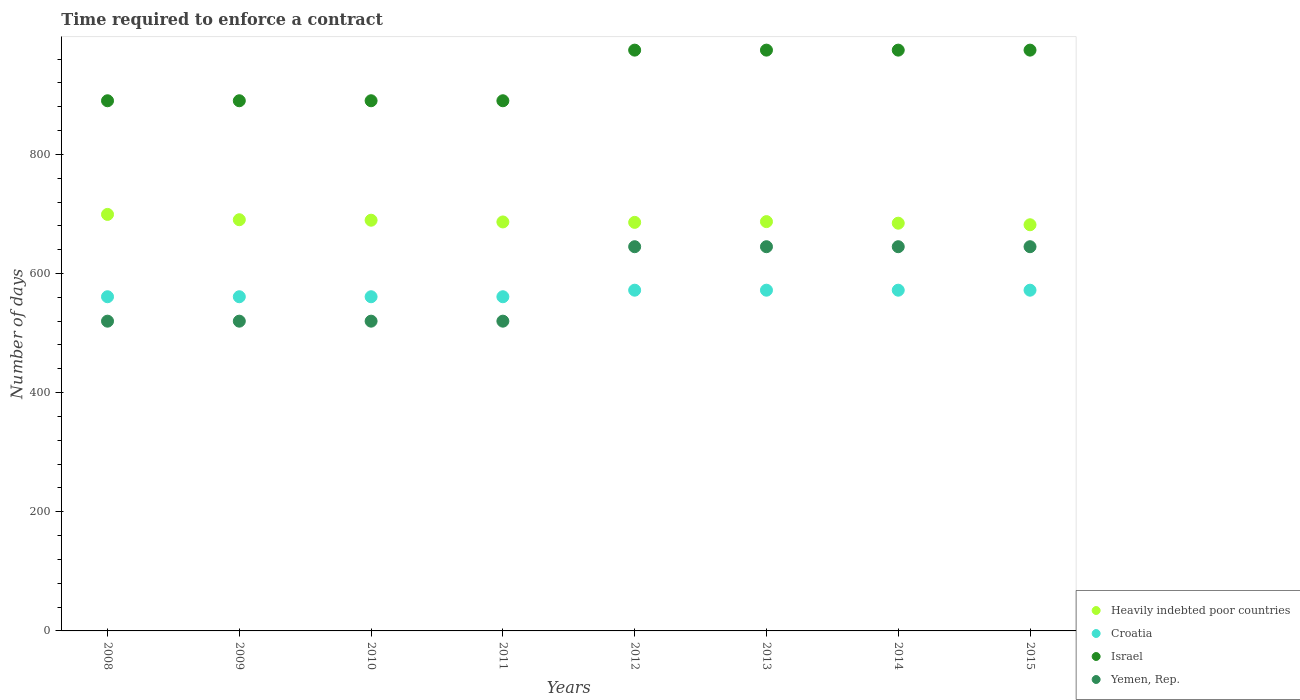How many different coloured dotlines are there?
Ensure brevity in your answer.  4. Is the number of dotlines equal to the number of legend labels?
Provide a succinct answer. Yes. What is the number of days required to enforce a contract in Heavily indebted poor countries in 2012?
Your response must be concise. 685.84. Across all years, what is the maximum number of days required to enforce a contract in Yemen, Rep.?
Make the answer very short. 645. Across all years, what is the minimum number of days required to enforce a contract in Israel?
Your answer should be very brief. 890. In which year was the number of days required to enforce a contract in Croatia maximum?
Provide a short and direct response. 2012. In which year was the number of days required to enforce a contract in Heavily indebted poor countries minimum?
Provide a succinct answer. 2015. What is the total number of days required to enforce a contract in Heavily indebted poor countries in the graph?
Your response must be concise. 5504.79. What is the difference between the number of days required to enforce a contract in Croatia in 2011 and that in 2012?
Provide a short and direct response. -11. What is the difference between the number of days required to enforce a contract in Yemen, Rep. in 2010 and the number of days required to enforce a contract in Croatia in 2009?
Ensure brevity in your answer.  -41. What is the average number of days required to enforce a contract in Croatia per year?
Ensure brevity in your answer.  566.5. In the year 2008, what is the difference between the number of days required to enforce a contract in Croatia and number of days required to enforce a contract in Yemen, Rep.?
Provide a short and direct response. 41. In how many years, is the number of days required to enforce a contract in Yemen, Rep. greater than 320 days?
Offer a terse response. 8. What is the difference between the highest and the second highest number of days required to enforce a contract in Heavily indebted poor countries?
Make the answer very short. 8.92. What is the difference between the highest and the lowest number of days required to enforce a contract in Heavily indebted poor countries?
Give a very brief answer. 17.37. Is it the case that in every year, the sum of the number of days required to enforce a contract in Yemen, Rep. and number of days required to enforce a contract in Israel  is greater than the sum of number of days required to enforce a contract in Croatia and number of days required to enforce a contract in Heavily indebted poor countries?
Give a very brief answer. Yes. Is it the case that in every year, the sum of the number of days required to enforce a contract in Heavily indebted poor countries and number of days required to enforce a contract in Croatia  is greater than the number of days required to enforce a contract in Israel?
Offer a very short reply. Yes. Does the number of days required to enforce a contract in Heavily indebted poor countries monotonically increase over the years?
Make the answer very short. No. Is the number of days required to enforce a contract in Heavily indebted poor countries strictly greater than the number of days required to enforce a contract in Yemen, Rep. over the years?
Your response must be concise. Yes. How many years are there in the graph?
Make the answer very short. 8. Are the values on the major ticks of Y-axis written in scientific E-notation?
Offer a terse response. No. Does the graph contain grids?
Your answer should be very brief. No. Where does the legend appear in the graph?
Keep it short and to the point. Bottom right. How many legend labels are there?
Your answer should be compact. 4. How are the legend labels stacked?
Provide a short and direct response. Vertical. What is the title of the graph?
Give a very brief answer. Time required to enforce a contract. What is the label or title of the X-axis?
Provide a succinct answer. Years. What is the label or title of the Y-axis?
Keep it short and to the point. Number of days. What is the Number of days of Heavily indebted poor countries in 2008?
Keep it short and to the point. 699.21. What is the Number of days of Croatia in 2008?
Provide a short and direct response. 561. What is the Number of days in Israel in 2008?
Provide a short and direct response. 890. What is the Number of days of Yemen, Rep. in 2008?
Offer a very short reply. 520. What is the Number of days of Heavily indebted poor countries in 2009?
Keep it short and to the point. 690.29. What is the Number of days of Croatia in 2009?
Offer a terse response. 561. What is the Number of days in Israel in 2009?
Keep it short and to the point. 890. What is the Number of days of Yemen, Rep. in 2009?
Keep it short and to the point. 520. What is the Number of days in Heavily indebted poor countries in 2010?
Your response must be concise. 689.47. What is the Number of days of Croatia in 2010?
Give a very brief answer. 561. What is the Number of days of Israel in 2010?
Ensure brevity in your answer.  890. What is the Number of days of Yemen, Rep. in 2010?
Keep it short and to the point. 520. What is the Number of days of Heavily indebted poor countries in 2011?
Your response must be concise. 686.55. What is the Number of days of Croatia in 2011?
Provide a short and direct response. 561. What is the Number of days in Israel in 2011?
Make the answer very short. 890. What is the Number of days in Yemen, Rep. in 2011?
Provide a short and direct response. 520. What is the Number of days of Heavily indebted poor countries in 2012?
Offer a terse response. 685.84. What is the Number of days in Croatia in 2012?
Offer a very short reply. 572. What is the Number of days of Israel in 2012?
Provide a short and direct response. 975. What is the Number of days of Yemen, Rep. in 2012?
Your response must be concise. 645. What is the Number of days in Heavily indebted poor countries in 2013?
Give a very brief answer. 687.11. What is the Number of days in Croatia in 2013?
Provide a short and direct response. 572. What is the Number of days of Israel in 2013?
Your answer should be compact. 975. What is the Number of days of Yemen, Rep. in 2013?
Ensure brevity in your answer.  645. What is the Number of days of Heavily indebted poor countries in 2014?
Keep it short and to the point. 684.47. What is the Number of days in Croatia in 2014?
Keep it short and to the point. 572. What is the Number of days in Israel in 2014?
Your answer should be very brief. 975. What is the Number of days of Yemen, Rep. in 2014?
Your answer should be very brief. 645. What is the Number of days in Heavily indebted poor countries in 2015?
Keep it short and to the point. 681.84. What is the Number of days in Croatia in 2015?
Ensure brevity in your answer.  572. What is the Number of days of Israel in 2015?
Offer a terse response. 975. What is the Number of days in Yemen, Rep. in 2015?
Keep it short and to the point. 645. Across all years, what is the maximum Number of days of Heavily indebted poor countries?
Make the answer very short. 699.21. Across all years, what is the maximum Number of days of Croatia?
Your response must be concise. 572. Across all years, what is the maximum Number of days of Israel?
Your response must be concise. 975. Across all years, what is the maximum Number of days in Yemen, Rep.?
Your answer should be very brief. 645. Across all years, what is the minimum Number of days in Heavily indebted poor countries?
Make the answer very short. 681.84. Across all years, what is the minimum Number of days in Croatia?
Give a very brief answer. 561. Across all years, what is the minimum Number of days of Israel?
Make the answer very short. 890. Across all years, what is the minimum Number of days in Yemen, Rep.?
Offer a very short reply. 520. What is the total Number of days in Heavily indebted poor countries in the graph?
Your response must be concise. 5504.79. What is the total Number of days of Croatia in the graph?
Offer a very short reply. 4532. What is the total Number of days of Israel in the graph?
Give a very brief answer. 7460. What is the total Number of days in Yemen, Rep. in the graph?
Your answer should be very brief. 4660. What is the difference between the Number of days in Heavily indebted poor countries in 2008 and that in 2009?
Ensure brevity in your answer.  8.92. What is the difference between the Number of days of Croatia in 2008 and that in 2009?
Provide a succinct answer. 0. What is the difference between the Number of days of Israel in 2008 and that in 2009?
Offer a terse response. 0. What is the difference between the Number of days of Yemen, Rep. in 2008 and that in 2009?
Your response must be concise. 0. What is the difference between the Number of days in Heavily indebted poor countries in 2008 and that in 2010?
Keep it short and to the point. 9.74. What is the difference between the Number of days in Croatia in 2008 and that in 2010?
Your answer should be compact. 0. What is the difference between the Number of days of Yemen, Rep. in 2008 and that in 2010?
Your answer should be very brief. 0. What is the difference between the Number of days of Heavily indebted poor countries in 2008 and that in 2011?
Make the answer very short. 12.66. What is the difference between the Number of days of Croatia in 2008 and that in 2011?
Give a very brief answer. 0. What is the difference between the Number of days in Israel in 2008 and that in 2011?
Your response must be concise. 0. What is the difference between the Number of days in Heavily indebted poor countries in 2008 and that in 2012?
Your answer should be very brief. 13.37. What is the difference between the Number of days in Croatia in 2008 and that in 2012?
Your answer should be compact. -11. What is the difference between the Number of days of Israel in 2008 and that in 2012?
Ensure brevity in your answer.  -85. What is the difference between the Number of days of Yemen, Rep. in 2008 and that in 2012?
Provide a succinct answer. -125. What is the difference between the Number of days of Heavily indebted poor countries in 2008 and that in 2013?
Ensure brevity in your answer.  12.11. What is the difference between the Number of days of Israel in 2008 and that in 2013?
Make the answer very short. -85. What is the difference between the Number of days in Yemen, Rep. in 2008 and that in 2013?
Your answer should be very brief. -125. What is the difference between the Number of days in Heavily indebted poor countries in 2008 and that in 2014?
Your response must be concise. 14.74. What is the difference between the Number of days in Israel in 2008 and that in 2014?
Ensure brevity in your answer.  -85. What is the difference between the Number of days of Yemen, Rep. in 2008 and that in 2014?
Ensure brevity in your answer.  -125. What is the difference between the Number of days of Heavily indebted poor countries in 2008 and that in 2015?
Provide a succinct answer. 17.37. What is the difference between the Number of days in Israel in 2008 and that in 2015?
Ensure brevity in your answer.  -85. What is the difference between the Number of days in Yemen, Rep. in 2008 and that in 2015?
Offer a terse response. -125. What is the difference between the Number of days of Heavily indebted poor countries in 2009 and that in 2010?
Give a very brief answer. 0.82. What is the difference between the Number of days in Croatia in 2009 and that in 2010?
Give a very brief answer. 0. What is the difference between the Number of days in Yemen, Rep. in 2009 and that in 2010?
Give a very brief answer. 0. What is the difference between the Number of days in Heavily indebted poor countries in 2009 and that in 2011?
Give a very brief answer. 3.74. What is the difference between the Number of days of Heavily indebted poor countries in 2009 and that in 2012?
Ensure brevity in your answer.  4.45. What is the difference between the Number of days of Israel in 2009 and that in 2012?
Provide a succinct answer. -85. What is the difference between the Number of days of Yemen, Rep. in 2009 and that in 2012?
Ensure brevity in your answer.  -125. What is the difference between the Number of days of Heavily indebted poor countries in 2009 and that in 2013?
Offer a very short reply. 3.18. What is the difference between the Number of days of Israel in 2009 and that in 2013?
Your answer should be compact. -85. What is the difference between the Number of days of Yemen, Rep. in 2009 and that in 2013?
Keep it short and to the point. -125. What is the difference between the Number of days of Heavily indebted poor countries in 2009 and that in 2014?
Your answer should be compact. 5.82. What is the difference between the Number of days in Croatia in 2009 and that in 2014?
Provide a short and direct response. -11. What is the difference between the Number of days of Israel in 2009 and that in 2014?
Keep it short and to the point. -85. What is the difference between the Number of days of Yemen, Rep. in 2009 and that in 2014?
Your response must be concise. -125. What is the difference between the Number of days of Heavily indebted poor countries in 2009 and that in 2015?
Provide a short and direct response. 8.45. What is the difference between the Number of days of Croatia in 2009 and that in 2015?
Offer a very short reply. -11. What is the difference between the Number of days of Israel in 2009 and that in 2015?
Provide a succinct answer. -85. What is the difference between the Number of days of Yemen, Rep. in 2009 and that in 2015?
Provide a short and direct response. -125. What is the difference between the Number of days in Heavily indebted poor countries in 2010 and that in 2011?
Ensure brevity in your answer.  2.92. What is the difference between the Number of days of Croatia in 2010 and that in 2011?
Ensure brevity in your answer.  0. What is the difference between the Number of days of Israel in 2010 and that in 2011?
Make the answer very short. 0. What is the difference between the Number of days of Heavily indebted poor countries in 2010 and that in 2012?
Your answer should be compact. 3.63. What is the difference between the Number of days in Croatia in 2010 and that in 2012?
Keep it short and to the point. -11. What is the difference between the Number of days in Israel in 2010 and that in 2012?
Make the answer very short. -85. What is the difference between the Number of days of Yemen, Rep. in 2010 and that in 2012?
Ensure brevity in your answer.  -125. What is the difference between the Number of days of Heavily indebted poor countries in 2010 and that in 2013?
Your answer should be very brief. 2.37. What is the difference between the Number of days in Israel in 2010 and that in 2013?
Your answer should be compact. -85. What is the difference between the Number of days in Yemen, Rep. in 2010 and that in 2013?
Provide a short and direct response. -125. What is the difference between the Number of days of Heavily indebted poor countries in 2010 and that in 2014?
Ensure brevity in your answer.  5. What is the difference between the Number of days of Croatia in 2010 and that in 2014?
Offer a very short reply. -11. What is the difference between the Number of days of Israel in 2010 and that in 2014?
Give a very brief answer. -85. What is the difference between the Number of days of Yemen, Rep. in 2010 and that in 2014?
Ensure brevity in your answer.  -125. What is the difference between the Number of days of Heavily indebted poor countries in 2010 and that in 2015?
Make the answer very short. 7.63. What is the difference between the Number of days of Israel in 2010 and that in 2015?
Make the answer very short. -85. What is the difference between the Number of days of Yemen, Rep. in 2010 and that in 2015?
Ensure brevity in your answer.  -125. What is the difference between the Number of days of Heavily indebted poor countries in 2011 and that in 2012?
Give a very brief answer. 0.71. What is the difference between the Number of days in Israel in 2011 and that in 2012?
Your answer should be compact. -85. What is the difference between the Number of days of Yemen, Rep. in 2011 and that in 2012?
Keep it short and to the point. -125. What is the difference between the Number of days of Heavily indebted poor countries in 2011 and that in 2013?
Make the answer very short. -0.55. What is the difference between the Number of days of Croatia in 2011 and that in 2013?
Your response must be concise. -11. What is the difference between the Number of days in Israel in 2011 and that in 2013?
Your answer should be very brief. -85. What is the difference between the Number of days of Yemen, Rep. in 2011 and that in 2013?
Ensure brevity in your answer.  -125. What is the difference between the Number of days of Heavily indebted poor countries in 2011 and that in 2014?
Your answer should be compact. 2.08. What is the difference between the Number of days in Croatia in 2011 and that in 2014?
Offer a terse response. -11. What is the difference between the Number of days of Israel in 2011 and that in 2014?
Give a very brief answer. -85. What is the difference between the Number of days in Yemen, Rep. in 2011 and that in 2014?
Your response must be concise. -125. What is the difference between the Number of days of Heavily indebted poor countries in 2011 and that in 2015?
Your response must be concise. 4.71. What is the difference between the Number of days in Israel in 2011 and that in 2015?
Provide a succinct answer. -85. What is the difference between the Number of days in Yemen, Rep. in 2011 and that in 2015?
Provide a succinct answer. -125. What is the difference between the Number of days of Heavily indebted poor countries in 2012 and that in 2013?
Your answer should be very brief. -1.26. What is the difference between the Number of days of Heavily indebted poor countries in 2012 and that in 2014?
Make the answer very short. 1.37. What is the difference between the Number of days of Croatia in 2012 and that in 2014?
Give a very brief answer. 0. What is the difference between the Number of days of Yemen, Rep. in 2012 and that in 2014?
Your answer should be compact. 0. What is the difference between the Number of days in Israel in 2012 and that in 2015?
Your response must be concise. 0. What is the difference between the Number of days in Heavily indebted poor countries in 2013 and that in 2014?
Give a very brief answer. 2.63. What is the difference between the Number of days in Israel in 2013 and that in 2014?
Keep it short and to the point. 0. What is the difference between the Number of days of Heavily indebted poor countries in 2013 and that in 2015?
Provide a short and direct response. 5.26. What is the difference between the Number of days in Croatia in 2013 and that in 2015?
Your response must be concise. 0. What is the difference between the Number of days in Israel in 2013 and that in 2015?
Your answer should be compact. 0. What is the difference between the Number of days in Heavily indebted poor countries in 2014 and that in 2015?
Make the answer very short. 2.63. What is the difference between the Number of days in Heavily indebted poor countries in 2008 and the Number of days in Croatia in 2009?
Ensure brevity in your answer.  138.21. What is the difference between the Number of days in Heavily indebted poor countries in 2008 and the Number of days in Israel in 2009?
Make the answer very short. -190.79. What is the difference between the Number of days in Heavily indebted poor countries in 2008 and the Number of days in Yemen, Rep. in 2009?
Offer a terse response. 179.21. What is the difference between the Number of days in Croatia in 2008 and the Number of days in Israel in 2009?
Offer a very short reply. -329. What is the difference between the Number of days of Croatia in 2008 and the Number of days of Yemen, Rep. in 2009?
Give a very brief answer. 41. What is the difference between the Number of days in Israel in 2008 and the Number of days in Yemen, Rep. in 2009?
Provide a short and direct response. 370. What is the difference between the Number of days in Heavily indebted poor countries in 2008 and the Number of days in Croatia in 2010?
Your answer should be very brief. 138.21. What is the difference between the Number of days in Heavily indebted poor countries in 2008 and the Number of days in Israel in 2010?
Offer a terse response. -190.79. What is the difference between the Number of days of Heavily indebted poor countries in 2008 and the Number of days of Yemen, Rep. in 2010?
Give a very brief answer. 179.21. What is the difference between the Number of days in Croatia in 2008 and the Number of days in Israel in 2010?
Your answer should be compact. -329. What is the difference between the Number of days of Croatia in 2008 and the Number of days of Yemen, Rep. in 2010?
Give a very brief answer. 41. What is the difference between the Number of days in Israel in 2008 and the Number of days in Yemen, Rep. in 2010?
Provide a short and direct response. 370. What is the difference between the Number of days in Heavily indebted poor countries in 2008 and the Number of days in Croatia in 2011?
Offer a very short reply. 138.21. What is the difference between the Number of days of Heavily indebted poor countries in 2008 and the Number of days of Israel in 2011?
Give a very brief answer. -190.79. What is the difference between the Number of days of Heavily indebted poor countries in 2008 and the Number of days of Yemen, Rep. in 2011?
Provide a short and direct response. 179.21. What is the difference between the Number of days of Croatia in 2008 and the Number of days of Israel in 2011?
Provide a succinct answer. -329. What is the difference between the Number of days of Israel in 2008 and the Number of days of Yemen, Rep. in 2011?
Provide a succinct answer. 370. What is the difference between the Number of days in Heavily indebted poor countries in 2008 and the Number of days in Croatia in 2012?
Ensure brevity in your answer.  127.21. What is the difference between the Number of days in Heavily indebted poor countries in 2008 and the Number of days in Israel in 2012?
Your answer should be compact. -275.79. What is the difference between the Number of days in Heavily indebted poor countries in 2008 and the Number of days in Yemen, Rep. in 2012?
Offer a very short reply. 54.21. What is the difference between the Number of days in Croatia in 2008 and the Number of days in Israel in 2012?
Your answer should be compact. -414. What is the difference between the Number of days of Croatia in 2008 and the Number of days of Yemen, Rep. in 2012?
Ensure brevity in your answer.  -84. What is the difference between the Number of days in Israel in 2008 and the Number of days in Yemen, Rep. in 2012?
Provide a succinct answer. 245. What is the difference between the Number of days of Heavily indebted poor countries in 2008 and the Number of days of Croatia in 2013?
Ensure brevity in your answer.  127.21. What is the difference between the Number of days of Heavily indebted poor countries in 2008 and the Number of days of Israel in 2013?
Offer a terse response. -275.79. What is the difference between the Number of days in Heavily indebted poor countries in 2008 and the Number of days in Yemen, Rep. in 2013?
Your answer should be compact. 54.21. What is the difference between the Number of days of Croatia in 2008 and the Number of days of Israel in 2013?
Offer a terse response. -414. What is the difference between the Number of days of Croatia in 2008 and the Number of days of Yemen, Rep. in 2013?
Keep it short and to the point. -84. What is the difference between the Number of days of Israel in 2008 and the Number of days of Yemen, Rep. in 2013?
Make the answer very short. 245. What is the difference between the Number of days in Heavily indebted poor countries in 2008 and the Number of days in Croatia in 2014?
Your response must be concise. 127.21. What is the difference between the Number of days of Heavily indebted poor countries in 2008 and the Number of days of Israel in 2014?
Give a very brief answer. -275.79. What is the difference between the Number of days in Heavily indebted poor countries in 2008 and the Number of days in Yemen, Rep. in 2014?
Ensure brevity in your answer.  54.21. What is the difference between the Number of days of Croatia in 2008 and the Number of days of Israel in 2014?
Ensure brevity in your answer.  -414. What is the difference between the Number of days in Croatia in 2008 and the Number of days in Yemen, Rep. in 2014?
Give a very brief answer. -84. What is the difference between the Number of days in Israel in 2008 and the Number of days in Yemen, Rep. in 2014?
Give a very brief answer. 245. What is the difference between the Number of days of Heavily indebted poor countries in 2008 and the Number of days of Croatia in 2015?
Provide a short and direct response. 127.21. What is the difference between the Number of days in Heavily indebted poor countries in 2008 and the Number of days in Israel in 2015?
Offer a very short reply. -275.79. What is the difference between the Number of days in Heavily indebted poor countries in 2008 and the Number of days in Yemen, Rep. in 2015?
Your answer should be very brief. 54.21. What is the difference between the Number of days of Croatia in 2008 and the Number of days of Israel in 2015?
Give a very brief answer. -414. What is the difference between the Number of days of Croatia in 2008 and the Number of days of Yemen, Rep. in 2015?
Offer a terse response. -84. What is the difference between the Number of days in Israel in 2008 and the Number of days in Yemen, Rep. in 2015?
Keep it short and to the point. 245. What is the difference between the Number of days in Heavily indebted poor countries in 2009 and the Number of days in Croatia in 2010?
Provide a succinct answer. 129.29. What is the difference between the Number of days in Heavily indebted poor countries in 2009 and the Number of days in Israel in 2010?
Your answer should be compact. -199.71. What is the difference between the Number of days of Heavily indebted poor countries in 2009 and the Number of days of Yemen, Rep. in 2010?
Make the answer very short. 170.29. What is the difference between the Number of days of Croatia in 2009 and the Number of days of Israel in 2010?
Offer a terse response. -329. What is the difference between the Number of days of Croatia in 2009 and the Number of days of Yemen, Rep. in 2010?
Your answer should be compact. 41. What is the difference between the Number of days of Israel in 2009 and the Number of days of Yemen, Rep. in 2010?
Ensure brevity in your answer.  370. What is the difference between the Number of days of Heavily indebted poor countries in 2009 and the Number of days of Croatia in 2011?
Keep it short and to the point. 129.29. What is the difference between the Number of days of Heavily indebted poor countries in 2009 and the Number of days of Israel in 2011?
Your response must be concise. -199.71. What is the difference between the Number of days in Heavily indebted poor countries in 2009 and the Number of days in Yemen, Rep. in 2011?
Make the answer very short. 170.29. What is the difference between the Number of days of Croatia in 2009 and the Number of days of Israel in 2011?
Your answer should be very brief. -329. What is the difference between the Number of days in Croatia in 2009 and the Number of days in Yemen, Rep. in 2011?
Offer a very short reply. 41. What is the difference between the Number of days in Israel in 2009 and the Number of days in Yemen, Rep. in 2011?
Give a very brief answer. 370. What is the difference between the Number of days in Heavily indebted poor countries in 2009 and the Number of days in Croatia in 2012?
Offer a very short reply. 118.29. What is the difference between the Number of days of Heavily indebted poor countries in 2009 and the Number of days of Israel in 2012?
Ensure brevity in your answer.  -284.71. What is the difference between the Number of days of Heavily indebted poor countries in 2009 and the Number of days of Yemen, Rep. in 2012?
Provide a short and direct response. 45.29. What is the difference between the Number of days of Croatia in 2009 and the Number of days of Israel in 2012?
Provide a short and direct response. -414. What is the difference between the Number of days in Croatia in 2009 and the Number of days in Yemen, Rep. in 2012?
Make the answer very short. -84. What is the difference between the Number of days of Israel in 2009 and the Number of days of Yemen, Rep. in 2012?
Your answer should be compact. 245. What is the difference between the Number of days of Heavily indebted poor countries in 2009 and the Number of days of Croatia in 2013?
Your answer should be very brief. 118.29. What is the difference between the Number of days of Heavily indebted poor countries in 2009 and the Number of days of Israel in 2013?
Your response must be concise. -284.71. What is the difference between the Number of days of Heavily indebted poor countries in 2009 and the Number of days of Yemen, Rep. in 2013?
Offer a terse response. 45.29. What is the difference between the Number of days in Croatia in 2009 and the Number of days in Israel in 2013?
Your answer should be very brief. -414. What is the difference between the Number of days of Croatia in 2009 and the Number of days of Yemen, Rep. in 2013?
Provide a short and direct response. -84. What is the difference between the Number of days of Israel in 2009 and the Number of days of Yemen, Rep. in 2013?
Make the answer very short. 245. What is the difference between the Number of days of Heavily indebted poor countries in 2009 and the Number of days of Croatia in 2014?
Provide a succinct answer. 118.29. What is the difference between the Number of days of Heavily indebted poor countries in 2009 and the Number of days of Israel in 2014?
Keep it short and to the point. -284.71. What is the difference between the Number of days of Heavily indebted poor countries in 2009 and the Number of days of Yemen, Rep. in 2014?
Provide a short and direct response. 45.29. What is the difference between the Number of days of Croatia in 2009 and the Number of days of Israel in 2014?
Your response must be concise. -414. What is the difference between the Number of days of Croatia in 2009 and the Number of days of Yemen, Rep. in 2014?
Offer a terse response. -84. What is the difference between the Number of days in Israel in 2009 and the Number of days in Yemen, Rep. in 2014?
Offer a terse response. 245. What is the difference between the Number of days of Heavily indebted poor countries in 2009 and the Number of days of Croatia in 2015?
Provide a short and direct response. 118.29. What is the difference between the Number of days of Heavily indebted poor countries in 2009 and the Number of days of Israel in 2015?
Give a very brief answer. -284.71. What is the difference between the Number of days in Heavily indebted poor countries in 2009 and the Number of days in Yemen, Rep. in 2015?
Keep it short and to the point. 45.29. What is the difference between the Number of days in Croatia in 2009 and the Number of days in Israel in 2015?
Keep it short and to the point. -414. What is the difference between the Number of days of Croatia in 2009 and the Number of days of Yemen, Rep. in 2015?
Give a very brief answer. -84. What is the difference between the Number of days in Israel in 2009 and the Number of days in Yemen, Rep. in 2015?
Keep it short and to the point. 245. What is the difference between the Number of days in Heavily indebted poor countries in 2010 and the Number of days in Croatia in 2011?
Your answer should be very brief. 128.47. What is the difference between the Number of days in Heavily indebted poor countries in 2010 and the Number of days in Israel in 2011?
Provide a short and direct response. -200.53. What is the difference between the Number of days in Heavily indebted poor countries in 2010 and the Number of days in Yemen, Rep. in 2011?
Make the answer very short. 169.47. What is the difference between the Number of days of Croatia in 2010 and the Number of days of Israel in 2011?
Make the answer very short. -329. What is the difference between the Number of days in Israel in 2010 and the Number of days in Yemen, Rep. in 2011?
Make the answer very short. 370. What is the difference between the Number of days in Heavily indebted poor countries in 2010 and the Number of days in Croatia in 2012?
Offer a terse response. 117.47. What is the difference between the Number of days of Heavily indebted poor countries in 2010 and the Number of days of Israel in 2012?
Your answer should be very brief. -285.53. What is the difference between the Number of days in Heavily indebted poor countries in 2010 and the Number of days in Yemen, Rep. in 2012?
Provide a short and direct response. 44.47. What is the difference between the Number of days of Croatia in 2010 and the Number of days of Israel in 2012?
Make the answer very short. -414. What is the difference between the Number of days of Croatia in 2010 and the Number of days of Yemen, Rep. in 2012?
Your response must be concise. -84. What is the difference between the Number of days of Israel in 2010 and the Number of days of Yemen, Rep. in 2012?
Your answer should be very brief. 245. What is the difference between the Number of days in Heavily indebted poor countries in 2010 and the Number of days in Croatia in 2013?
Ensure brevity in your answer.  117.47. What is the difference between the Number of days in Heavily indebted poor countries in 2010 and the Number of days in Israel in 2013?
Your answer should be very brief. -285.53. What is the difference between the Number of days in Heavily indebted poor countries in 2010 and the Number of days in Yemen, Rep. in 2013?
Provide a succinct answer. 44.47. What is the difference between the Number of days of Croatia in 2010 and the Number of days of Israel in 2013?
Keep it short and to the point. -414. What is the difference between the Number of days of Croatia in 2010 and the Number of days of Yemen, Rep. in 2013?
Ensure brevity in your answer.  -84. What is the difference between the Number of days of Israel in 2010 and the Number of days of Yemen, Rep. in 2013?
Your answer should be compact. 245. What is the difference between the Number of days in Heavily indebted poor countries in 2010 and the Number of days in Croatia in 2014?
Offer a very short reply. 117.47. What is the difference between the Number of days in Heavily indebted poor countries in 2010 and the Number of days in Israel in 2014?
Offer a terse response. -285.53. What is the difference between the Number of days in Heavily indebted poor countries in 2010 and the Number of days in Yemen, Rep. in 2014?
Offer a very short reply. 44.47. What is the difference between the Number of days in Croatia in 2010 and the Number of days in Israel in 2014?
Offer a very short reply. -414. What is the difference between the Number of days of Croatia in 2010 and the Number of days of Yemen, Rep. in 2014?
Offer a very short reply. -84. What is the difference between the Number of days of Israel in 2010 and the Number of days of Yemen, Rep. in 2014?
Keep it short and to the point. 245. What is the difference between the Number of days of Heavily indebted poor countries in 2010 and the Number of days of Croatia in 2015?
Provide a short and direct response. 117.47. What is the difference between the Number of days in Heavily indebted poor countries in 2010 and the Number of days in Israel in 2015?
Ensure brevity in your answer.  -285.53. What is the difference between the Number of days of Heavily indebted poor countries in 2010 and the Number of days of Yemen, Rep. in 2015?
Keep it short and to the point. 44.47. What is the difference between the Number of days in Croatia in 2010 and the Number of days in Israel in 2015?
Ensure brevity in your answer.  -414. What is the difference between the Number of days of Croatia in 2010 and the Number of days of Yemen, Rep. in 2015?
Offer a very short reply. -84. What is the difference between the Number of days in Israel in 2010 and the Number of days in Yemen, Rep. in 2015?
Your answer should be very brief. 245. What is the difference between the Number of days of Heavily indebted poor countries in 2011 and the Number of days of Croatia in 2012?
Your response must be concise. 114.55. What is the difference between the Number of days in Heavily indebted poor countries in 2011 and the Number of days in Israel in 2012?
Your answer should be very brief. -288.45. What is the difference between the Number of days in Heavily indebted poor countries in 2011 and the Number of days in Yemen, Rep. in 2012?
Provide a short and direct response. 41.55. What is the difference between the Number of days of Croatia in 2011 and the Number of days of Israel in 2012?
Keep it short and to the point. -414. What is the difference between the Number of days of Croatia in 2011 and the Number of days of Yemen, Rep. in 2012?
Keep it short and to the point. -84. What is the difference between the Number of days of Israel in 2011 and the Number of days of Yemen, Rep. in 2012?
Your answer should be very brief. 245. What is the difference between the Number of days of Heavily indebted poor countries in 2011 and the Number of days of Croatia in 2013?
Offer a very short reply. 114.55. What is the difference between the Number of days in Heavily indebted poor countries in 2011 and the Number of days in Israel in 2013?
Ensure brevity in your answer.  -288.45. What is the difference between the Number of days in Heavily indebted poor countries in 2011 and the Number of days in Yemen, Rep. in 2013?
Your response must be concise. 41.55. What is the difference between the Number of days of Croatia in 2011 and the Number of days of Israel in 2013?
Your answer should be very brief. -414. What is the difference between the Number of days in Croatia in 2011 and the Number of days in Yemen, Rep. in 2013?
Your response must be concise. -84. What is the difference between the Number of days in Israel in 2011 and the Number of days in Yemen, Rep. in 2013?
Provide a short and direct response. 245. What is the difference between the Number of days in Heavily indebted poor countries in 2011 and the Number of days in Croatia in 2014?
Offer a very short reply. 114.55. What is the difference between the Number of days of Heavily indebted poor countries in 2011 and the Number of days of Israel in 2014?
Ensure brevity in your answer.  -288.45. What is the difference between the Number of days of Heavily indebted poor countries in 2011 and the Number of days of Yemen, Rep. in 2014?
Give a very brief answer. 41.55. What is the difference between the Number of days in Croatia in 2011 and the Number of days in Israel in 2014?
Keep it short and to the point. -414. What is the difference between the Number of days in Croatia in 2011 and the Number of days in Yemen, Rep. in 2014?
Your answer should be compact. -84. What is the difference between the Number of days in Israel in 2011 and the Number of days in Yemen, Rep. in 2014?
Provide a succinct answer. 245. What is the difference between the Number of days in Heavily indebted poor countries in 2011 and the Number of days in Croatia in 2015?
Make the answer very short. 114.55. What is the difference between the Number of days in Heavily indebted poor countries in 2011 and the Number of days in Israel in 2015?
Offer a very short reply. -288.45. What is the difference between the Number of days of Heavily indebted poor countries in 2011 and the Number of days of Yemen, Rep. in 2015?
Make the answer very short. 41.55. What is the difference between the Number of days in Croatia in 2011 and the Number of days in Israel in 2015?
Provide a short and direct response. -414. What is the difference between the Number of days of Croatia in 2011 and the Number of days of Yemen, Rep. in 2015?
Provide a short and direct response. -84. What is the difference between the Number of days of Israel in 2011 and the Number of days of Yemen, Rep. in 2015?
Your response must be concise. 245. What is the difference between the Number of days of Heavily indebted poor countries in 2012 and the Number of days of Croatia in 2013?
Give a very brief answer. 113.84. What is the difference between the Number of days in Heavily indebted poor countries in 2012 and the Number of days in Israel in 2013?
Your answer should be compact. -289.16. What is the difference between the Number of days in Heavily indebted poor countries in 2012 and the Number of days in Yemen, Rep. in 2013?
Provide a short and direct response. 40.84. What is the difference between the Number of days of Croatia in 2012 and the Number of days of Israel in 2013?
Offer a very short reply. -403. What is the difference between the Number of days of Croatia in 2012 and the Number of days of Yemen, Rep. in 2013?
Ensure brevity in your answer.  -73. What is the difference between the Number of days in Israel in 2012 and the Number of days in Yemen, Rep. in 2013?
Keep it short and to the point. 330. What is the difference between the Number of days of Heavily indebted poor countries in 2012 and the Number of days of Croatia in 2014?
Give a very brief answer. 113.84. What is the difference between the Number of days in Heavily indebted poor countries in 2012 and the Number of days in Israel in 2014?
Give a very brief answer. -289.16. What is the difference between the Number of days of Heavily indebted poor countries in 2012 and the Number of days of Yemen, Rep. in 2014?
Your response must be concise. 40.84. What is the difference between the Number of days in Croatia in 2012 and the Number of days in Israel in 2014?
Keep it short and to the point. -403. What is the difference between the Number of days in Croatia in 2012 and the Number of days in Yemen, Rep. in 2014?
Offer a terse response. -73. What is the difference between the Number of days in Israel in 2012 and the Number of days in Yemen, Rep. in 2014?
Offer a terse response. 330. What is the difference between the Number of days in Heavily indebted poor countries in 2012 and the Number of days in Croatia in 2015?
Your response must be concise. 113.84. What is the difference between the Number of days of Heavily indebted poor countries in 2012 and the Number of days of Israel in 2015?
Your answer should be compact. -289.16. What is the difference between the Number of days of Heavily indebted poor countries in 2012 and the Number of days of Yemen, Rep. in 2015?
Offer a terse response. 40.84. What is the difference between the Number of days in Croatia in 2012 and the Number of days in Israel in 2015?
Your answer should be very brief. -403. What is the difference between the Number of days of Croatia in 2012 and the Number of days of Yemen, Rep. in 2015?
Your response must be concise. -73. What is the difference between the Number of days in Israel in 2012 and the Number of days in Yemen, Rep. in 2015?
Your answer should be very brief. 330. What is the difference between the Number of days of Heavily indebted poor countries in 2013 and the Number of days of Croatia in 2014?
Provide a succinct answer. 115.11. What is the difference between the Number of days of Heavily indebted poor countries in 2013 and the Number of days of Israel in 2014?
Your response must be concise. -287.89. What is the difference between the Number of days of Heavily indebted poor countries in 2013 and the Number of days of Yemen, Rep. in 2014?
Your answer should be compact. 42.11. What is the difference between the Number of days of Croatia in 2013 and the Number of days of Israel in 2014?
Give a very brief answer. -403. What is the difference between the Number of days in Croatia in 2013 and the Number of days in Yemen, Rep. in 2014?
Your answer should be very brief. -73. What is the difference between the Number of days in Israel in 2013 and the Number of days in Yemen, Rep. in 2014?
Make the answer very short. 330. What is the difference between the Number of days of Heavily indebted poor countries in 2013 and the Number of days of Croatia in 2015?
Give a very brief answer. 115.11. What is the difference between the Number of days of Heavily indebted poor countries in 2013 and the Number of days of Israel in 2015?
Offer a terse response. -287.89. What is the difference between the Number of days in Heavily indebted poor countries in 2013 and the Number of days in Yemen, Rep. in 2015?
Make the answer very short. 42.11. What is the difference between the Number of days in Croatia in 2013 and the Number of days in Israel in 2015?
Your response must be concise. -403. What is the difference between the Number of days of Croatia in 2013 and the Number of days of Yemen, Rep. in 2015?
Give a very brief answer. -73. What is the difference between the Number of days of Israel in 2013 and the Number of days of Yemen, Rep. in 2015?
Ensure brevity in your answer.  330. What is the difference between the Number of days in Heavily indebted poor countries in 2014 and the Number of days in Croatia in 2015?
Your response must be concise. 112.47. What is the difference between the Number of days of Heavily indebted poor countries in 2014 and the Number of days of Israel in 2015?
Your response must be concise. -290.53. What is the difference between the Number of days of Heavily indebted poor countries in 2014 and the Number of days of Yemen, Rep. in 2015?
Keep it short and to the point. 39.47. What is the difference between the Number of days in Croatia in 2014 and the Number of days in Israel in 2015?
Provide a succinct answer. -403. What is the difference between the Number of days in Croatia in 2014 and the Number of days in Yemen, Rep. in 2015?
Offer a very short reply. -73. What is the difference between the Number of days in Israel in 2014 and the Number of days in Yemen, Rep. in 2015?
Offer a terse response. 330. What is the average Number of days of Heavily indebted poor countries per year?
Your answer should be compact. 688.1. What is the average Number of days of Croatia per year?
Make the answer very short. 566.5. What is the average Number of days of Israel per year?
Your response must be concise. 932.5. What is the average Number of days in Yemen, Rep. per year?
Your answer should be compact. 582.5. In the year 2008, what is the difference between the Number of days of Heavily indebted poor countries and Number of days of Croatia?
Your response must be concise. 138.21. In the year 2008, what is the difference between the Number of days in Heavily indebted poor countries and Number of days in Israel?
Your answer should be compact. -190.79. In the year 2008, what is the difference between the Number of days of Heavily indebted poor countries and Number of days of Yemen, Rep.?
Provide a short and direct response. 179.21. In the year 2008, what is the difference between the Number of days in Croatia and Number of days in Israel?
Provide a short and direct response. -329. In the year 2008, what is the difference between the Number of days of Croatia and Number of days of Yemen, Rep.?
Provide a short and direct response. 41. In the year 2008, what is the difference between the Number of days in Israel and Number of days in Yemen, Rep.?
Provide a short and direct response. 370. In the year 2009, what is the difference between the Number of days of Heavily indebted poor countries and Number of days of Croatia?
Make the answer very short. 129.29. In the year 2009, what is the difference between the Number of days of Heavily indebted poor countries and Number of days of Israel?
Provide a succinct answer. -199.71. In the year 2009, what is the difference between the Number of days of Heavily indebted poor countries and Number of days of Yemen, Rep.?
Offer a terse response. 170.29. In the year 2009, what is the difference between the Number of days of Croatia and Number of days of Israel?
Your answer should be compact. -329. In the year 2009, what is the difference between the Number of days of Israel and Number of days of Yemen, Rep.?
Your response must be concise. 370. In the year 2010, what is the difference between the Number of days in Heavily indebted poor countries and Number of days in Croatia?
Your response must be concise. 128.47. In the year 2010, what is the difference between the Number of days of Heavily indebted poor countries and Number of days of Israel?
Offer a very short reply. -200.53. In the year 2010, what is the difference between the Number of days in Heavily indebted poor countries and Number of days in Yemen, Rep.?
Make the answer very short. 169.47. In the year 2010, what is the difference between the Number of days of Croatia and Number of days of Israel?
Your answer should be compact. -329. In the year 2010, what is the difference between the Number of days in Croatia and Number of days in Yemen, Rep.?
Offer a very short reply. 41. In the year 2010, what is the difference between the Number of days in Israel and Number of days in Yemen, Rep.?
Your answer should be compact. 370. In the year 2011, what is the difference between the Number of days of Heavily indebted poor countries and Number of days of Croatia?
Your response must be concise. 125.55. In the year 2011, what is the difference between the Number of days of Heavily indebted poor countries and Number of days of Israel?
Offer a terse response. -203.45. In the year 2011, what is the difference between the Number of days in Heavily indebted poor countries and Number of days in Yemen, Rep.?
Give a very brief answer. 166.55. In the year 2011, what is the difference between the Number of days of Croatia and Number of days of Israel?
Provide a succinct answer. -329. In the year 2011, what is the difference between the Number of days of Croatia and Number of days of Yemen, Rep.?
Provide a short and direct response. 41. In the year 2011, what is the difference between the Number of days of Israel and Number of days of Yemen, Rep.?
Ensure brevity in your answer.  370. In the year 2012, what is the difference between the Number of days of Heavily indebted poor countries and Number of days of Croatia?
Ensure brevity in your answer.  113.84. In the year 2012, what is the difference between the Number of days of Heavily indebted poor countries and Number of days of Israel?
Offer a very short reply. -289.16. In the year 2012, what is the difference between the Number of days in Heavily indebted poor countries and Number of days in Yemen, Rep.?
Your answer should be compact. 40.84. In the year 2012, what is the difference between the Number of days in Croatia and Number of days in Israel?
Make the answer very short. -403. In the year 2012, what is the difference between the Number of days in Croatia and Number of days in Yemen, Rep.?
Provide a short and direct response. -73. In the year 2012, what is the difference between the Number of days in Israel and Number of days in Yemen, Rep.?
Your answer should be compact. 330. In the year 2013, what is the difference between the Number of days of Heavily indebted poor countries and Number of days of Croatia?
Ensure brevity in your answer.  115.11. In the year 2013, what is the difference between the Number of days in Heavily indebted poor countries and Number of days in Israel?
Your answer should be compact. -287.89. In the year 2013, what is the difference between the Number of days of Heavily indebted poor countries and Number of days of Yemen, Rep.?
Your response must be concise. 42.11. In the year 2013, what is the difference between the Number of days of Croatia and Number of days of Israel?
Make the answer very short. -403. In the year 2013, what is the difference between the Number of days of Croatia and Number of days of Yemen, Rep.?
Provide a succinct answer. -73. In the year 2013, what is the difference between the Number of days in Israel and Number of days in Yemen, Rep.?
Provide a short and direct response. 330. In the year 2014, what is the difference between the Number of days in Heavily indebted poor countries and Number of days in Croatia?
Your response must be concise. 112.47. In the year 2014, what is the difference between the Number of days in Heavily indebted poor countries and Number of days in Israel?
Your answer should be compact. -290.53. In the year 2014, what is the difference between the Number of days in Heavily indebted poor countries and Number of days in Yemen, Rep.?
Make the answer very short. 39.47. In the year 2014, what is the difference between the Number of days in Croatia and Number of days in Israel?
Your response must be concise. -403. In the year 2014, what is the difference between the Number of days of Croatia and Number of days of Yemen, Rep.?
Offer a very short reply. -73. In the year 2014, what is the difference between the Number of days of Israel and Number of days of Yemen, Rep.?
Your answer should be very brief. 330. In the year 2015, what is the difference between the Number of days of Heavily indebted poor countries and Number of days of Croatia?
Your answer should be compact. 109.84. In the year 2015, what is the difference between the Number of days in Heavily indebted poor countries and Number of days in Israel?
Your answer should be compact. -293.16. In the year 2015, what is the difference between the Number of days of Heavily indebted poor countries and Number of days of Yemen, Rep.?
Make the answer very short. 36.84. In the year 2015, what is the difference between the Number of days in Croatia and Number of days in Israel?
Make the answer very short. -403. In the year 2015, what is the difference between the Number of days in Croatia and Number of days in Yemen, Rep.?
Keep it short and to the point. -73. In the year 2015, what is the difference between the Number of days of Israel and Number of days of Yemen, Rep.?
Provide a short and direct response. 330. What is the ratio of the Number of days in Heavily indebted poor countries in 2008 to that in 2009?
Your response must be concise. 1.01. What is the ratio of the Number of days in Croatia in 2008 to that in 2009?
Offer a terse response. 1. What is the ratio of the Number of days in Yemen, Rep. in 2008 to that in 2009?
Provide a short and direct response. 1. What is the ratio of the Number of days of Heavily indebted poor countries in 2008 to that in 2010?
Offer a terse response. 1.01. What is the ratio of the Number of days in Heavily indebted poor countries in 2008 to that in 2011?
Offer a terse response. 1.02. What is the ratio of the Number of days in Croatia in 2008 to that in 2011?
Make the answer very short. 1. What is the ratio of the Number of days in Israel in 2008 to that in 2011?
Provide a succinct answer. 1. What is the ratio of the Number of days of Yemen, Rep. in 2008 to that in 2011?
Ensure brevity in your answer.  1. What is the ratio of the Number of days in Heavily indebted poor countries in 2008 to that in 2012?
Provide a short and direct response. 1.02. What is the ratio of the Number of days in Croatia in 2008 to that in 2012?
Your answer should be very brief. 0.98. What is the ratio of the Number of days in Israel in 2008 to that in 2012?
Provide a succinct answer. 0.91. What is the ratio of the Number of days in Yemen, Rep. in 2008 to that in 2012?
Make the answer very short. 0.81. What is the ratio of the Number of days of Heavily indebted poor countries in 2008 to that in 2013?
Provide a short and direct response. 1.02. What is the ratio of the Number of days in Croatia in 2008 to that in 2013?
Provide a short and direct response. 0.98. What is the ratio of the Number of days of Israel in 2008 to that in 2013?
Give a very brief answer. 0.91. What is the ratio of the Number of days of Yemen, Rep. in 2008 to that in 2013?
Ensure brevity in your answer.  0.81. What is the ratio of the Number of days of Heavily indebted poor countries in 2008 to that in 2014?
Ensure brevity in your answer.  1.02. What is the ratio of the Number of days of Croatia in 2008 to that in 2014?
Offer a very short reply. 0.98. What is the ratio of the Number of days of Israel in 2008 to that in 2014?
Your response must be concise. 0.91. What is the ratio of the Number of days in Yemen, Rep. in 2008 to that in 2014?
Provide a succinct answer. 0.81. What is the ratio of the Number of days in Heavily indebted poor countries in 2008 to that in 2015?
Provide a short and direct response. 1.03. What is the ratio of the Number of days in Croatia in 2008 to that in 2015?
Your answer should be compact. 0.98. What is the ratio of the Number of days of Israel in 2008 to that in 2015?
Ensure brevity in your answer.  0.91. What is the ratio of the Number of days of Yemen, Rep. in 2008 to that in 2015?
Keep it short and to the point. 0.81. What is the ratio of the Number of days in Croatia in 2009 to that in 2010?
Your response must be concise. 1. What is the ratio of the Number of days of Israel in 2009 to that in 2010?
Offer a terse response. 1. What is the ratio of the Number of days in Yemen, Rep. in 2009 to that in 2010?
Your answer should be compact. 1. What is the ratio of the Number of days of Heavily indebted poor countries in 2009 to that in 2011?
Make the answer very short. 1.01. What is the ratio of the Number of days of Yemen, Rep. in 2009 to that in 2011?
Your answer should be very brief. 1. What is the ratio of the Number of days in Heavily indebted poor countries in 2009 to that in 2012?
Offer a terse response. 1.01. What is the ratio of the Number of days in Croatia in 2009 to that in 2012?
Provide a succinct answer. 0.98. What is the ratio of the Number of days of Israel in 2009 to that in 2012?
Provide a short and direct response. 0.91. What is the ratio of the Number of days in Yemen, Rep. in 2009 to that in 2012?
Make the answer very short. 0.81. What is the ratio of the Number of days in Heavily indebted poor countries in 2009 to that in 2013?
Your answer should be compact. 1. What is the ratio of the Number of days in Croatia in 2009 to that in 2013?
Ensure brevity in your answer.  0.98. What is the ratio of the Number of days in Israel in 2009 to that in 2013?
Offer a terse response. 0.91. What is the ratio of the Number of days in Yemen, Rep. in 2009 to that in 2013?
Give a very brief answer. 0.81. What is the ratio of the Number of days in Heavily indebted poor countries in 2009 to that in 2014?
Give a very brief answer. 1.01. What is the ratio of the Number of days in Croatia in 2009 to that in 2014?
Provide a short and direct response. 0.98. What is the ratio of the Number of days in Israel in 2009 to that in 2014?
Give a very brief answer. 0.91. What is the ratio of the Number of days in Yemen, Rep. in 2009 to that in 2014?
Offer a very short reply. 0.81. What is the ratio of the Number of days of Heavily indebted poor countries in 2009 to that in 2015?
Offer a terse response. 1.01. What is the ratio of the Number of days in Croatia in 2009 to that in 2015?
Provide a succinct answer. 0.98. What is the ratio of the Number of days of Israel in 2009 to that in 2015?
Offer a terse response. 0.91. What is the ratio of the Number of days of Yemen, Rep. in 2009 to that in 2015?
Your answer should be compact. 0.81. What is the ratio of the Number of days in Heavily indebted poor countries in 2010 to that in 2012?
Your answer should be compact. 1.01. What is the ratio of the Number of days in Croatia in 2010 to that in 2012?
Make the answer very short. 0.98. What is the ratio of the Number of days of Israel in 2010 to that in 2012?
Provide a succinct answer. 0.91. What is the ratio of the Number of days of Yemen, Rep. in 2010 to that in 2012?
Offer a terse response. 0.81. What is the ratio of the Number of days in Croatia in 2010 to that in 2013?
Your response must be concise. 0.98. What is the ratio of the Number of days in Israel in 2010 to that in 2013?
Offer a very short reply. 0.91. What is the ratio of the Number of days of Yemen, Rep. in 2010 to that in 2013?
Offer a terse response. 0.81. What is the ratio of the Number of days of Heavily indebted poor countries in 2010 to that in 2014?
Offer a very short reply. 1.01. What is the ratio of the Number of days of Croatia in 2010 to that in 2014?
Give a very brief answer. 0.98. What is the ratio of the Number of days of Israel in 2010 to that in 2014?
Provide a succinct answer. 0.91. What is the ratio of the Number of days in Yemen, Rep. in 2010 to that in 2014?
Keep it short and to the point. 0.81. What is the ratio of the Number of days in Heavily indebted poor countries in 2010 to that in 2015?
Offer a terse response. 1.01. What is the ratio of the Number of days in Croatia in 2010 to that in 2015?
Your answer should be very brief. 0.98. What is the ratio of the Number of days in Israel in 2010 to that in 2015?
Offer a very short reply. 0.91. What is the ratio of the Number of days in Yemen, Rep. in 2010 to that in 2015?
Your answer should be very brief. 0.81. What is the ratio of the Number of days in Croatia in 2011 to that in 2012?
Make the answer very short. 0.98. What is the ratio of the Number of days in Israel in 2011 to that in 2012?
Your response must be concise. 0.91. What is the ratio of the Number of days of Yemen, Rep. in 2011 to that in 2012?
Offer a very short reply. 0.81. What is the ratio of the Number of days of Heavily indebted poor countries in 2011 to that in 2013?
Provide a succinct answer. 1. What is the ratio of the Number of days in Croatia in 2011 to that in 2013?
Make the answer very short. 0.98. What is the ratio of the Number of days of Israel in 2011 to that in 2013?
Provide a succinct answer. 0.91. What is the ratio of the Number of days in Yemen, Rep. in 2011 to that in 2013?
Your answer should be very brief. 0.81. What is the ratio of the Number of days of Croatia in 2011 to that in 2014?
Your answer should be very brief. 0.98. What is the ratio of the Number of days in Israel in 2011 to that in 2014?
Ensure brevity in your answer.  0.91. What is the ratio of the Number of days of Yemen, Rep. in 2011 to that in 2014?
Your answer should be very brief. 0.81. What is the ratio of the Number of days in Croatia in 2011 to that in 2015?
Your answer should be compact. 0.98. What is the ratio of the Number of days in Israel in 2011 to that in 2015?
Your answer should be compact. 0.91. What is the ratio of the Number of days in Yemen, Rep. in 2011 to that in 2015?
Make the answer very short. 0.81. What is the ratio of the Number of days in Israel in 2012 to that in 2013?
Provide a short and direct response. 1. What is the ratio of the Number of days in Yemen, Rep. in 2012 to that in 2013?
Make the answer very short. 1. What is the ratio of the Number of days of Yemen, Rep. in 2012 to that in 2014?
Keep it short and to the point. 1. What is the ratio of the Number of days of Heavily indebted poor countries in 2012 to that in 2015?
Your answer should be very brief. 1.01. What is the ratio of the Number of days of Israel in 2012 to that in 2015?
Keep it short and to the point. 1. What is the ratio of the Number of days in Yemen, Rep. in 2013 to that in 2014?
Keep it short and to the point. 1. What is the ratio of the Number of days of Heavily indebted poor countries in 2013 to that in 2015?
Make the answer very short. 1.01. What is the ratio of the Number of days in Croatia in 2013 to that in 2015?
Your response must be concise. 1. What is the ratio of the Number of days of Israel in 2013 to that in 2015?
Give a very brief answer. 1. What is the ratio of the Number of days of Croatia in 2014 to that in 2015?
Provide a succinct answer. 1. What is the ratio of the Number of days of Israel in 2014 to that in 2015?
Your answer should be very brief. 1. What is the difference between the highest and the second highest Number of days in Heavily indebted poor countries?
Provide a succinct answer. 8.92. What is the difference between the highest and the second highest Number of days in Croatia?
Your response must be concise. 0. What is the difference between the highest and the lowest Number of days of Heavily indebted poor countries?
Keep it short and to the point. 17.37. What is the difference between the highest and the lowest Number of days of Israel?
Give a very brief answer. 85. What is the difference between the highest and the lowest Number of days in Yemen, Rep.?
Keep it short and to the point. 125. 